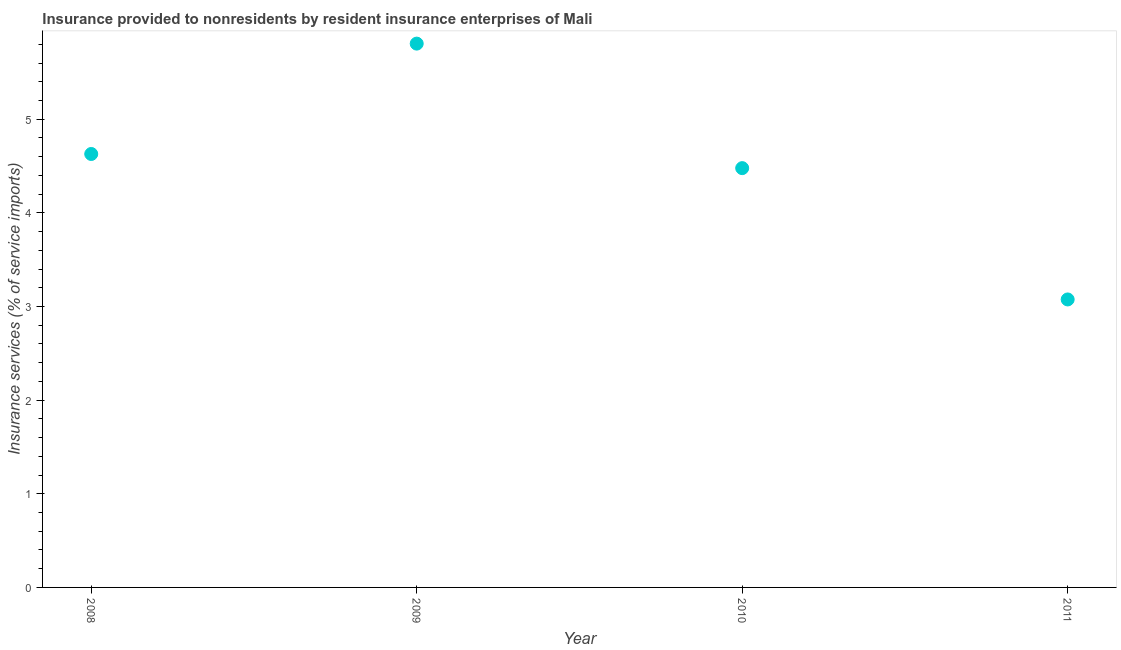What is the insurance and financial services in 2010?
Your response must be concise. 4.48. Across all years, what is the maximum insurance and financial services?
Provide a succinct answer. 5.81. Across all years, what is the minimum insurance and financial services?
Your response must be concise. 3.08. In which year was the insurance and financial services maximum?
Ensure brevity in your answer.  2009. In which year was the insurance and financial services minimum?
Provide a short and direct response. 2011. What is the sum of the insurance and financial services?
Offer a terse response. 17.99. What is the difference between the insurance and financial services in 2009 and 2011?
Your answer should be compact. 2.73. What is the average insurance and financial services per year?
Ensure brevity in your answer.  4.5. What is the median insurance and financial services?
Provide a succinct answer. 4.55. In how many years, is the insurance and financial services greater than 0.8 %?
Your answer should be very brief. 4. What is the ratio of the insurance and financial services in 2009 to that in 2010?
Make the answer very short. 1.3. What is the difference between the highest and the second highest insurance and financial services?
Your answer should be compact. 1.18. Is the sum of the insurance and financial services in 2009 and 2011 greater than the maximum insurance and financial services across all years?
Make the answer very short. Yes. What is the difference between the highest and the lowest insurance and financial services?
Offer a very short reply. 2.73. How many years are there in the graph?
Keep it short and to the point. 4. What is the difference between two consecutive major ticks on the Y-axis?
Offer a very short reply. 1. Are the values on the major ticks of Y-axis written in scientific E-notation?
Provide a succinct answer. No. What is the title of the graph?
Keep it short and to the point. Insurance provided to nonresidents by resident insurance enterprises of Mali. What is the label or title of the X-axis?
Make the answer very short. Year. What is the label or title of the Y-axis?
Keep it short and to the point. Insurance services (% of service imports). What is the Insurance services (% of service imports) in 2008?
Your answer should be compact. 4.63. What is the Insurance services (% of service imports) in 2009?
Provide a short and direct response. 5.81. What is the Insurance services (% of service imports) in 2010?
Your response must be concise. 4.48. What is the Insurance services (% of service imports) in 2011?
Your answer should be very brief. 3.08. What is the difference between the Insurance services (% of service imports) in 2008 and 2009?
Your answer should be compact. -1.18. What is the difference between the Insurance services (% of service imports) in 2008 and 2010?
Offer a very short reply. 0.15. What is the difference between the Insurance services (% of service imports) in 2008 and 2011?
Give a very brief answer. 1.55. What is the difference between the Insurance services (% of service imports) in 2009 and 2010?
Ensure brevity in your answer.  1.33. What is the difference between the Insurance services (% of service imports) in 2009 and 2011?
Provide a short and direct response. 2.73. What is the difference between the Insurance services (% of service imports) in 2010 and 2011?
Ensure brevity in your answer.  1.4. What is the ratio of the Insurance services (% of service imports) in 2008 to that in 2009?
Offer a terse response. 0.8. What is the ratio of the Insurance services (% of service imports) in 2008 to that in 2010?
Give a very brief answer. 1.03. What is the ratio of the Insurance services (% of service imports) in 2008 to that in 2011?
Your response must be concise. 1.5. What is the ratio of the Insurance services (% of service imports) in 2009 to that in 2010?
Offer a terse response. 1.3. What is the ratio of the Insurance services (% of service imports) in 2009 to that in 2011?
Keep it short and to the point. 1.89. What is the ratio of the Insurance services (% of service imports) in 2010 to that in 2011?
Your answer should be very brief. 1.46. 